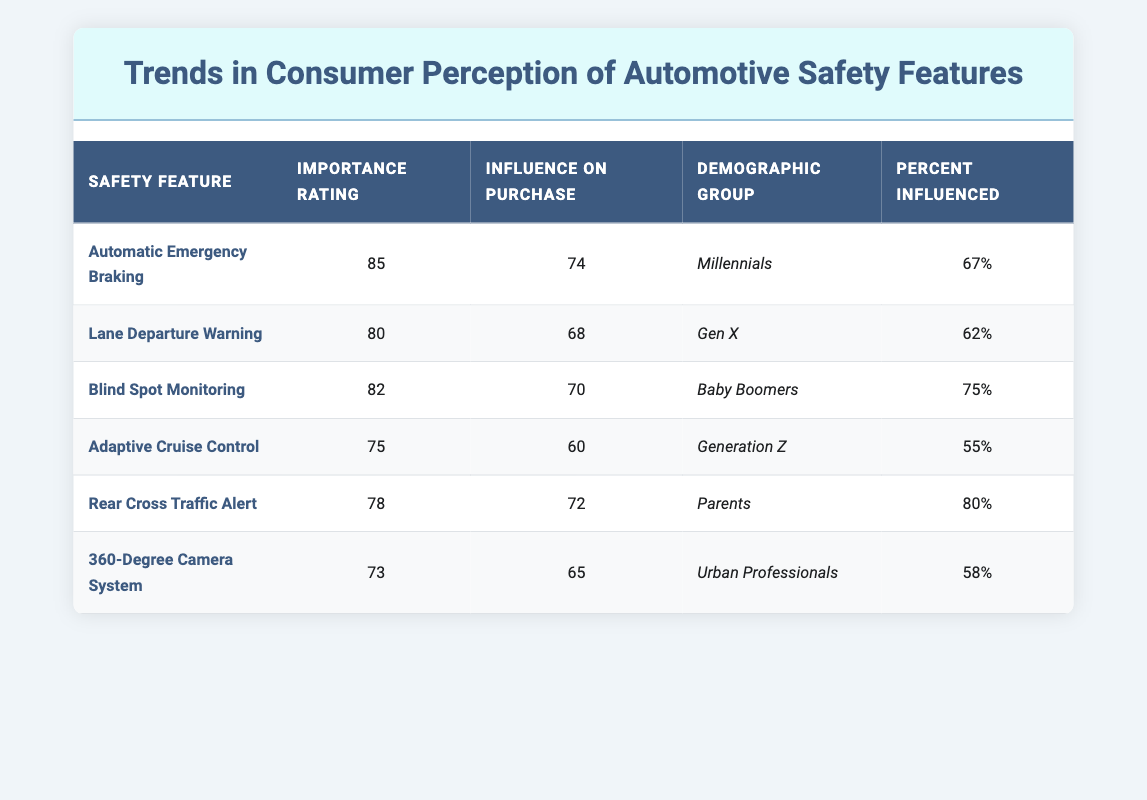What is the importance rating of Automatic Emergency Braking? The importance rating for Automatic Emergency Braking is listed directly in the table under the "Importance Rating" column. It is 85.
Answer: 85 Which safety feature has the highest influence on purchase decisions? Looking at the "Influence on Purchase" column, the highest value is 74 for Automatic Emergency Braking, making it the feature with the highest influence.
Answer: Automatic Emergency Braking Is the influence on purchase decision for Rear Cross Traffic Alert greater than that of Adaptive Cruise Control? Comparing the "Influence on Purchase" values for both features, Rear Cross Traffic Alert has a value of 72 and Adaptive Cruise Control has a value of 60. Since 72 is greater than 60, the statement is true.
Answer: Yes What is the average percent influenced across all demographic groups for Lane Departure Warning and Blind Spot Monitoring? The percent influenced for Lane Departure Warning is 62% and for Blind Spot Monitoring is 75%. Summing these values gives 137, and dividing by 2 shows the average is 68.5%.
Answer: 68.5% For which demographic group is Adaptive Cruise Control the feature with the lowest influence on purchase decisions? In the table, the influence on purchase for Adaptive Cruise Control is listed as 60, which is lower than all other features for Generation Z. Therefore, it can be confirmed that it has the lowest influence for that group.
Answer: Yes What is the difference in importance rating between Blind Spot Monitoring and Rear Cross Traffic Alert? The importance rating for Blind Spot Monitoring is 82 and for Rear Cross Traffic Alert is 78. Subtracting 78 from 82 gives a difference of 4.
Answer: 4 How many features have an influence on purchase decision of 70 or higher? By counting the features with an "Influence on Purchase" rating of 70 and higher, we see Automatic Emergency Braking (74), Blind Spot Monitoring (70), and Rear Cross Traffic Alert (72). This totals 3 features.
Answer: 3 Is the percent influenced by safety features for Urban Professionals greater than that for Parents? The percent influenced for Urban Professionals is 58%, while for Parents it is 80%. Since 58% is less than 80%, the answer is no.
Answer: No What is the significance of the demographic group with the highest influence on purchase decisions? By examining the "Percent Influenced" column, Parents show the highest influence at 80% for the feature Rear Cross Traffic Alert. This reflects the importance of safety features for this demographic when purchasing vehicles.
Answer: Parents (80%) 